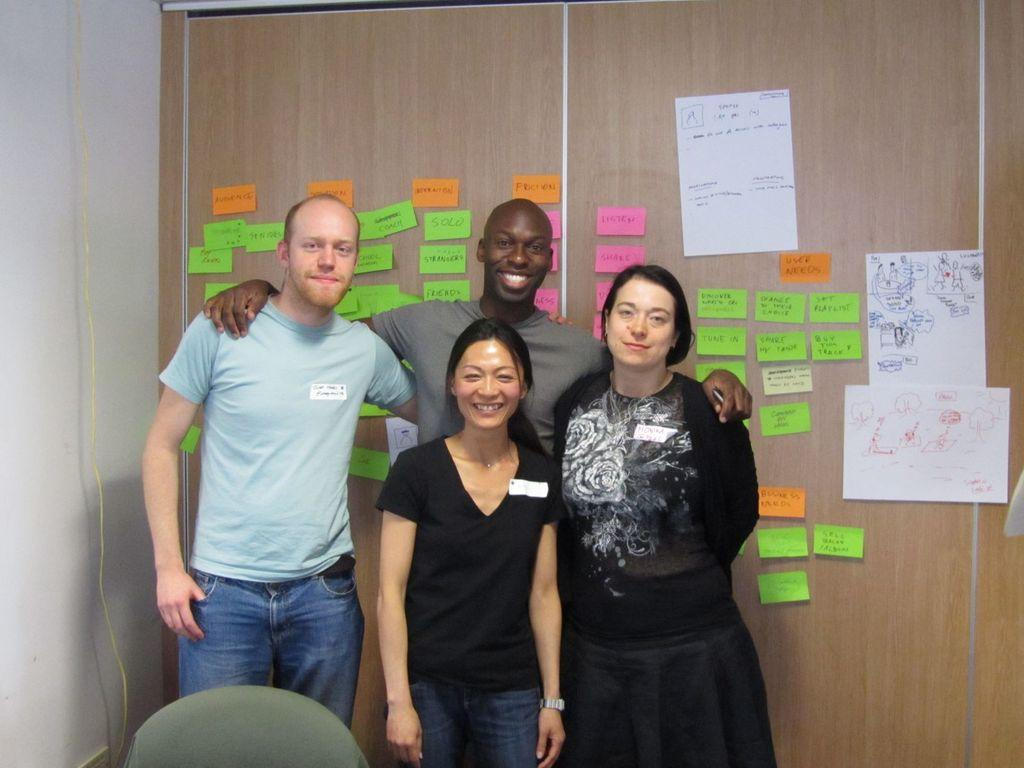What are the people in the image doing? The people in the image are standing and smiling. Can you describe the object in the image? Unfortunately, the facts provided do not give a description of the object in the image. What can be seen in the background of the image? In the background of the image, there are posters and stickers on a board or wall. Is there any wire visible in the image? Yes, there is a wire in the image. How many zebras are balancing on the wire in the image? There are no zebras present in the image, and therefore no zebras are balancing on the wire. What is the fifth object in the image? The facts provided do not list five objects in the image, so it is impossible to identify a fifth object. 